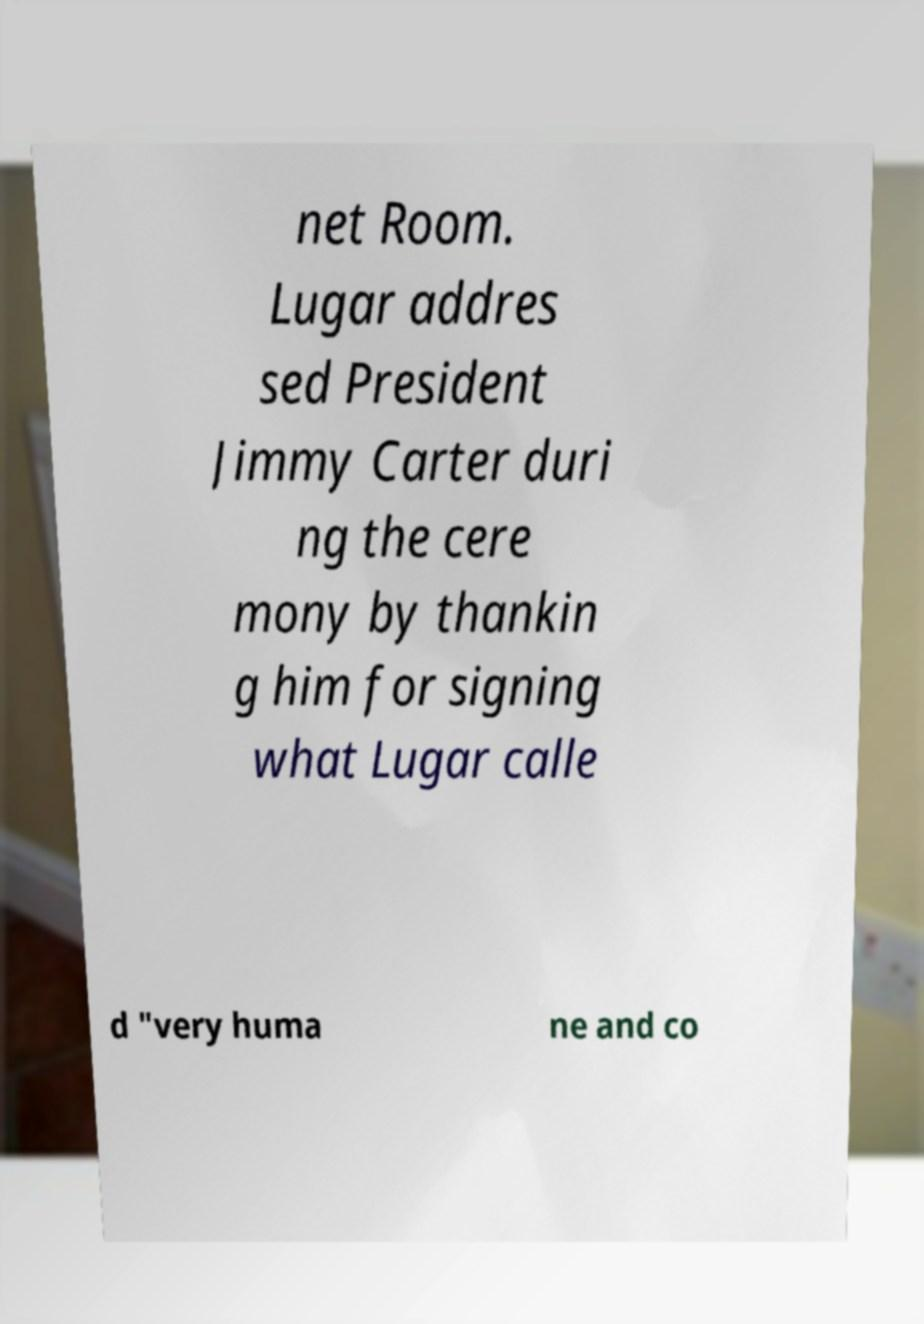Can you read and provide the text displayed in the image?This photo seems to have some interesting text. Can you extract and type it out for me? net Room. Lugar addres sed President Jimmy Carter duri ng the cere mony by thankin g him for signing what Lugar calle d "very huma ne and co 